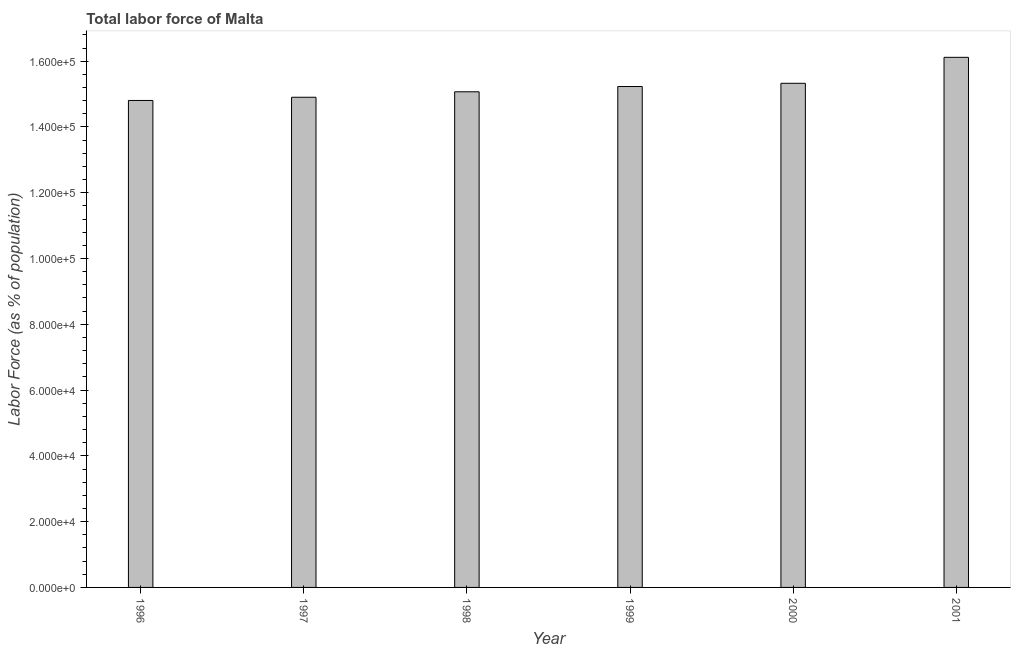Does the graph contain any zero values?
Offer a very short reply. No. What is the title of the graph?
Your answer should be very brief. Total labor force of Malta. What is the label or title of the Y-axis?
Provide a succinct answer. Labor Force (as % of population). What is the total labor force in 1998?
Provide a short and direct response. 1.51e+05. Across all years, what is the maximum total labor force?
Provide a short and direct response. 1.61e+05. Across all years, what is the minimum total labor force?
Offer a very short reply. 1.48e+05. In which year was the total labor force maximum?
Offer a very short reply. 2001. What is the sum of the total labor force?
Your answer should be very brief. 9.15e+05. What is the difference between the total labor force in 1996 and 1999?
Your answer should be very brief. -4239. What is the average total labor force per year?
Make the answer very short. 1.52e+05. What is the median total labor force?
Ensure brevity in your answer.  1.51e+05. Do a majority of the years between 1999 and 2001 (inclusive) have total labor force greater than 148000 %?
Offer a terse response. Yes. What is the ratio of the total labor force in 1996 to that in 1998?
Provide a short and direct response. 0.98. Is the difference between the total labor force in 1997 and 1998 greater than the difference between any two years?
Your response must be concise. No. What is the difference between the highest and the second highest total labor force?
Make the answer very short. 7897. What is the difference between the highest and the lowest total labor force?
Give a very brief answer. 1.31e+04. In how many years, is the total labor force greater than the average total labor force taken over all years?
Your answer should be very brief. 2. Are the values on the major ticks of Y-axis written in scientific E-notation?
Offer a very short reply. Yes. What is the Labor Force (as % of population) of 1996?
Your answer should be compact. 1.48e+05. What is the Labor Force (as % of population) of 1997?
Offer a very short reply. 1.49e+05. What is the Labor Force (as % of population) in 1998?
Provide a succinct answer. 1.51e+05. What is the Labor Force (as % of population) of 1999?
Make the answer very short. 1.52e+05. What is the Labor Force (as % of population) of 2000?
Give a very brief answer. 1.53e+05. What is the Labor Force (as % of population) in 2001?
Your answer should be compact. 1.61e+05. What is the difference between the Labor Force (as % of population) in 1996 and 1997?
Your response must be concise. -974. What is the difference between the Labor Force (as % of population) in 1996 and 1998?
Ensure brevity in your answer.  -2638. What is the difference between the Labor Force (as % of population) in 1996 and 1999?
Ensure brevity in your answer.  -4239. What is the difference between the Labor Force (as % of population) in 1996 and 2000?
Provide a succinct answer. -5216. What is the difference between the Labor Force (as % of population) in 1996 and 2001?
Ensure brevity in your answer.  -1.31e+04. What is the difference between the Labor Force (as % of population) in 1997 and 1998?
Keep it short and to the point. -1664. What is the difference between the Labor Force (as % of population) in 1997 and 1999?
Offer a terse response. -3265. What is the difference between the Labor Force (as % of population) in 1997 and 2000?
Make the answer very short. -4242. What is the difference between the Labor Force (as % of population) in 1997 and 2001?
Offer a terse response. -1.21e+04. What is the difference between the Labor Force (as % of population) in 1998 and 1999?
Keep it short and to the point. -1601. What is the difference between the Labor Force (as % of population) in 1998 and 2000?
Your answer should be very brief. -2578. What is the difference between the Labor Force (as % of population) in 1998 and 2001?
Give a very brief answer. -1.05e+04. What is the difference between the Labor Force (as % of population) in 1999 and 2000?
Your answer should be compact. -977. What is the difference between the Labor Force (as % of population) in 1999 and 2001?
Make the answer very short. -8874. What is the difference between the Labor Force (as % of population) in 2000 and 2001?
Provide a short and direct response. -7897. What is the ratio of the Labor Force (as % of population) in 1996 to that in 2001?
Your answer should be compact. 0.92. What is the ratio of the Labor Force (as % of population) in 1997 to that in 2000?
Your response must be concise. 0.97. What is the ratio of the Labor Force (as % of population) in 1997 to that in 2001?
Keep it short and to the point. 0.93. What is the ratio of the Labor Force (as % of population) in 1998 to that in 1999?
Your answer should be compact. 0.99. What is the ratio of the Labor Force (as % of population) in 1998 to that in 2000?
Provide a succinct answer. 0.98. What is the ratio of the Labor Force (as % of population) in 1998 to that in 2001?
Ensure brevity in your answer.  0.94. What is the ratio of the Labor Force (as % of population) in 1999 to that in 2000?
Make the answer very short. 0.99. What is the ratio of the Labor Force (as % of population) in 1999 to that in 2001?
Offer a very short reply. 0.94. What is the ratio of the Labor Force (as % of population) in 2000 to that in 2001?
Provide a succinct answer. 0.95. 